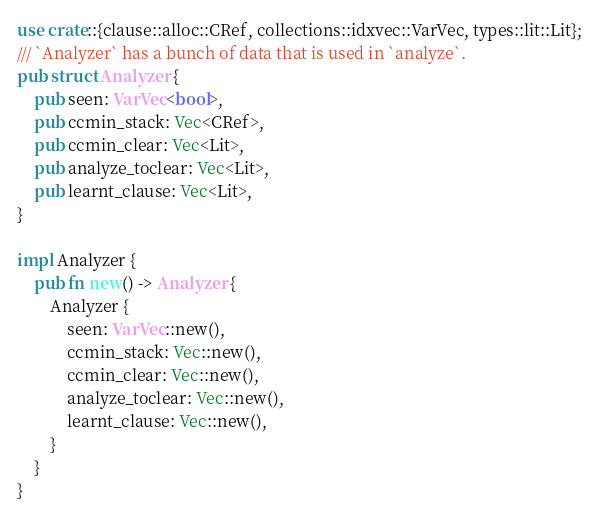<code> <loc_0><loc_0><loc_500><loc_500><_Rust_>use crate::{clause::alloc::CRef, collections::idxvec::VarVec, types::lit::Lit};
/// `Analyzer` has a bunch of data that is used in `analyze`.
pub struct Analyzer {
    pub seen: VarVec<bool>,
    pub ccmin_stack: Vec<CRef>,
    pub ccmin_clear: Vec<Lit>,
    pub analyze_toclear: Vec<Lit>,
    pub learnt_clause: Vec<Lit>,
}

impl Analyzer {
    pub fn new() -> Analyzer {
        Analyzer {
            seen: VarVec::new(),
            ccmin_stack: Vec::new(),
            ccmin_clear: Vec::new(),
            analyze_toclear: Vec::new(),
            learnt_clause: Vec::new(),
        }
    }
}
</code> 